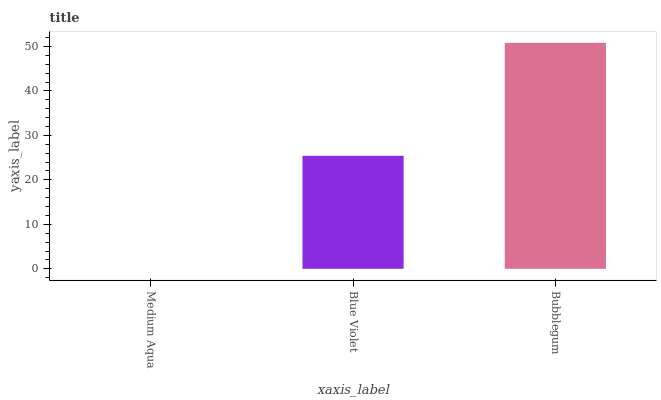Is Medium Aqua the minimum?
Answer yes or no. Yes. Is Bubblegum the maximum?
Answer yes or no. Yes. Is Blue Violet the minimum?
Answer yes or no. No. Is Blue Violet the maximum?
Answer yes or no. No. Is Blue Violet greater than Medium Aqua?
Answer yes or no. Yes. Is Medium Aqua less than Blue Violet?
Answer yes or no. Yes. Is Medium Aqua greater than Blue Violet?
Answer yes or no. No. Is Blue Violet less than Medium Aqua?
Answer yes or no. No. Is Blue Violet the high median?
Answer yes or no. Yes. Is Blue Violet the low median?
Answer yes or no. Yes. Is Medium Aqua the high median?
Answer yes or no. No. Is Bubblegum the low median?
Answer yes or no. No. 